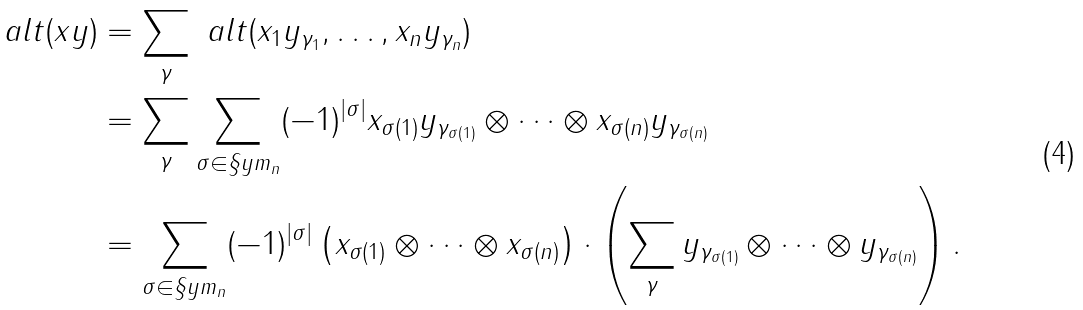Convert formula to latex. <formula><loc_0><loc_0><loc_500><loc_500>\ a l t ( { x y } ) & = \sum _ { \gamma } \ a l t ( x _ { 1 } y _ { \gamma _ { 1 } } , \dots , x _ { n } y _ { \gamma _ { n } } ) \\ & = \sum _ { \gamma } \sum _ { \sigma \in \S y m _ { n } } ( - 1 ) ^ { | \sigma | } x _ { \sigma ( 1 ) } y _ { \gamma _ { \sigma ( 1 ) } } \otimes \cdots \otimes x _ { \sigma ( n ) } y _ { \gamma _ { \sigma ( n ) } } \\ & = \sum _ { \sigma \in \S y m _ { n } } ( - 1 ) ^ { | \sigma | } \left ( x _ { \sigma ( 1 ) } \otimes \cdots \otimes x _ { \sigma ( n ) } \right ) \cdot \left ( \sum _ { \gamma } y _ { \gamma _ { \sigma ( 1 ) } } \otimes \cdots \otimes y _ { \gamma _ { \sigma ( n ) } } \right ) .</formula> 